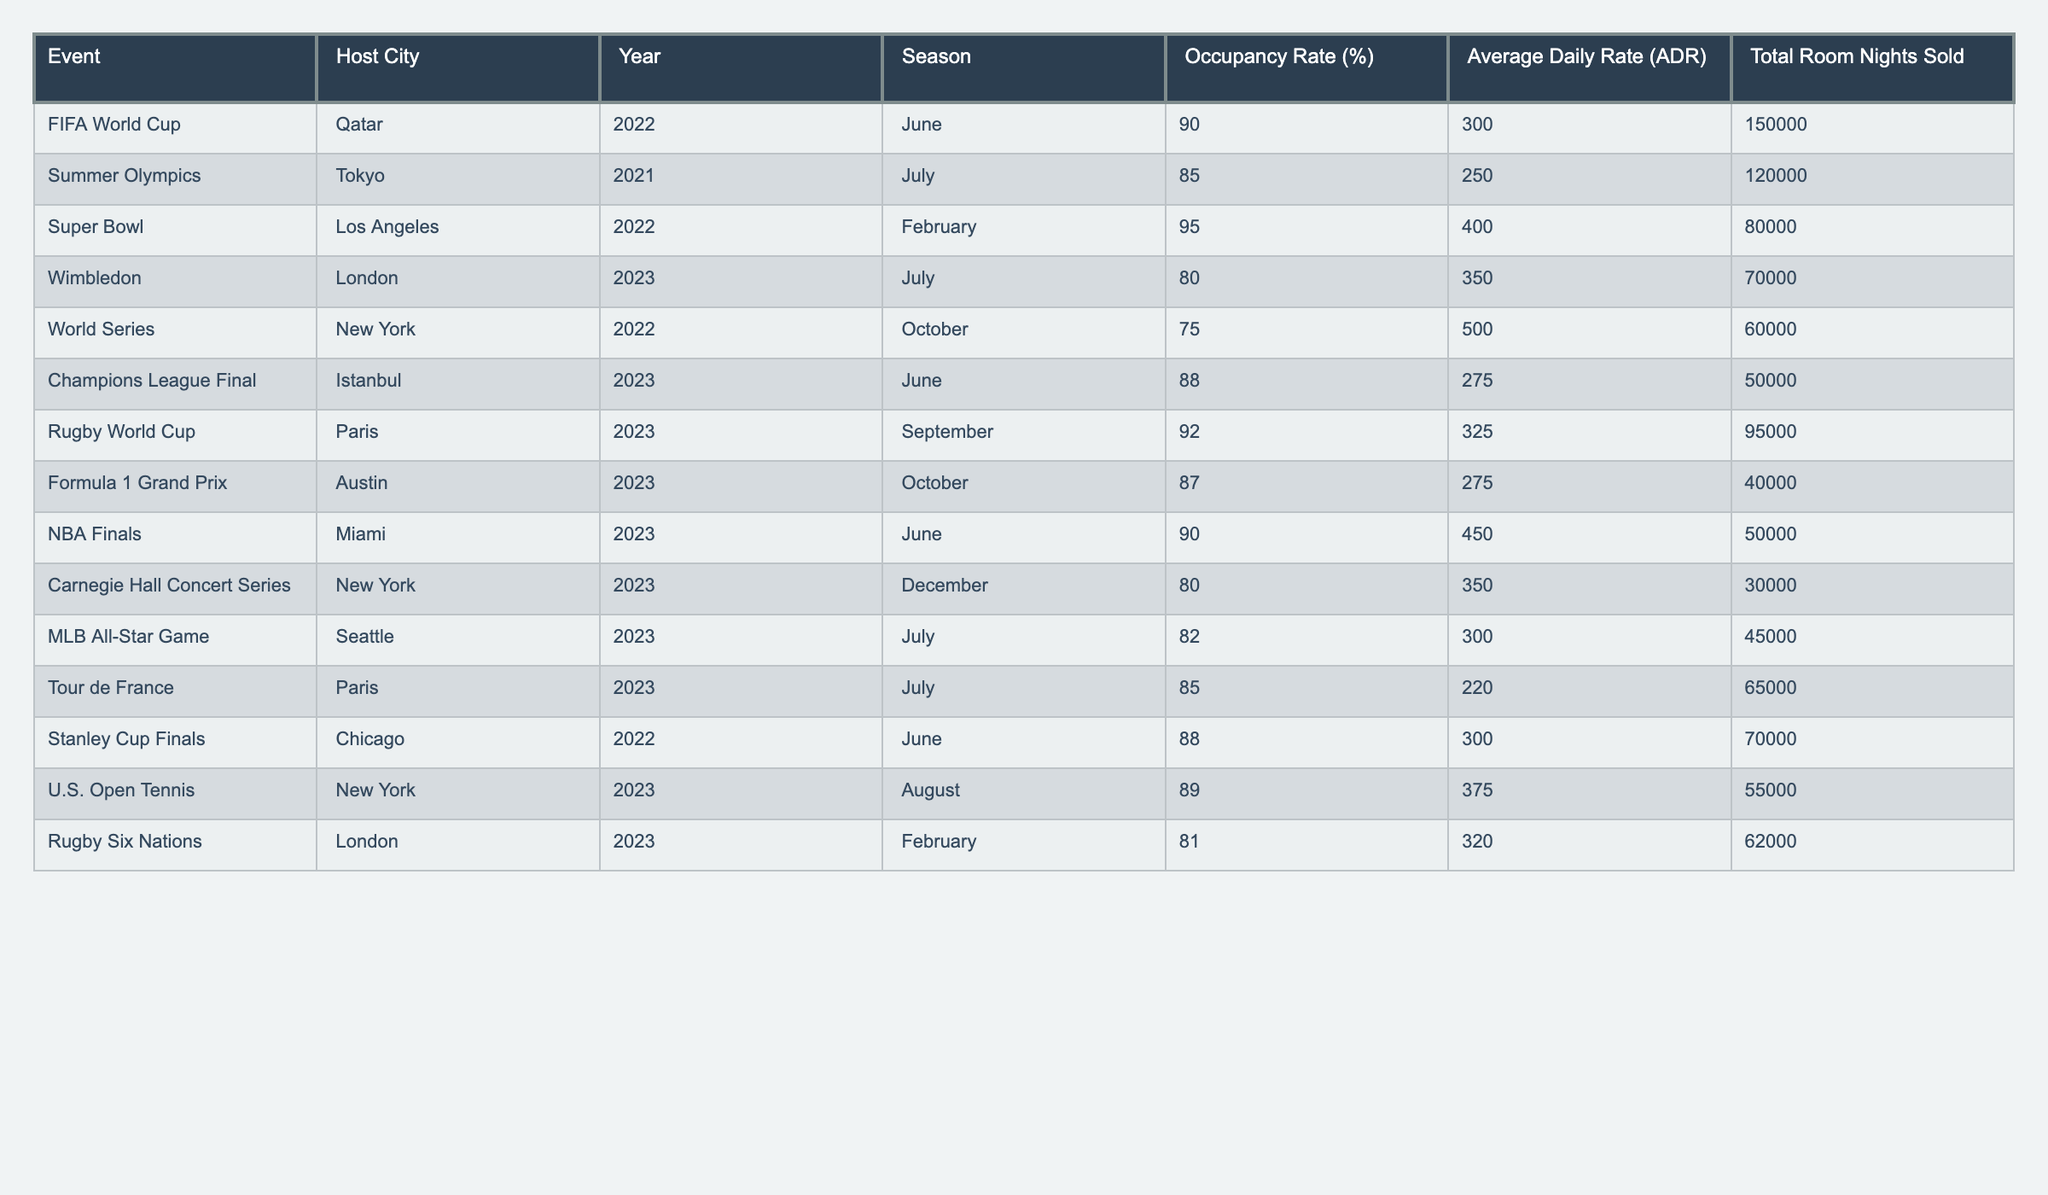What event had the highest occupancy rate? The table lists various events along with their occupancy rates. The Super Bowl in Los Angeles had the highest occupancy rate at 95%.
Answer: 95% In which host city did the Rugby World Cup take place? The table indicates that the Rugby World Cup was held in Paris in 2023.
Answer: Paris What was the average occupancy rate for events held in July? July events include the Summer Olympics (85%), Wimbledon (80%), MLB All-Star Game (82%), and Tour de France (85%). The average is (85 + 80 + 82 + 85) / 4 = 83%.
Answer: 83% Did the Champions League Final achieve an occupancy rate above 85%? The Champions League Final had an occupancy rate of 88%, which is above 85%.
Answer: Yes What is the difference in average daily rate between the Super Bowl and the Stanley Cup Finals? The average daily rate for the Super Bowl is 400 and for the Stanley Cup Finals, it’s 300. The difference is 400 - 300 = 100.
Answer: 100 What was the total room nights sold for the FIFA World Cup? According to the table, the FIFA World Cup sold 150,000 room nights.
Answer: 150000 Which event in October had the lowest occupancy rate, and what was it? The events in October were the World Series (75%) and Formula 1 Grand Prix (87%). The World Series had the lowest occupancy rate at 75%.
Answer: 75% How does the occupancy rate of the Rugby World Cup compare to that of the Tour de France? The Rugby World Cup occupancy rate is 92%, while the Tour de France's is 85%. The Rugby World Cup has a higher rate by 7%.
Answer: 7% What was the total room nights sold for events held in June? In June, the Super Bowl sold 80,000 and the Stanley Cup Finals sold 70,000. Total room nights sold is 80,000 + 70,000 = 150,000.
Answer: 150000 Are there any events with more than 90% occupancy rate besides the Super Bowl? The Rugby World Cup also had an occupancy rate of 92%, which is more than 90%.
Answer: Yes 